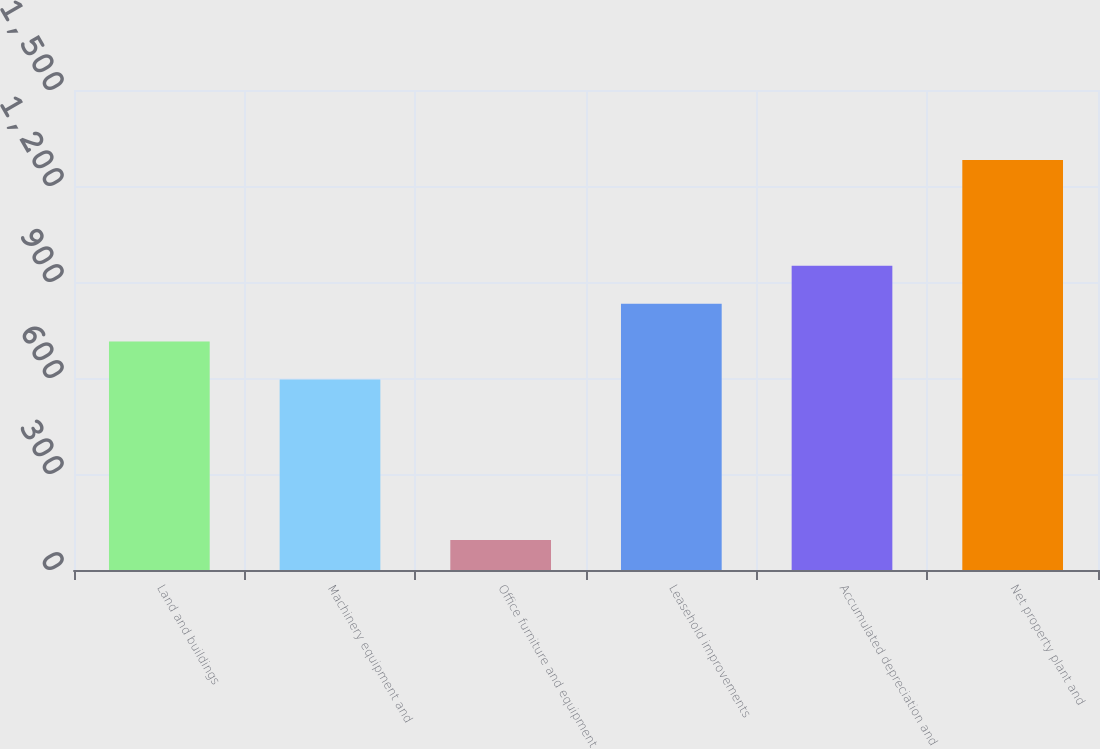<chart> <loc_0><loc_0><loc_500><loc_500><bar_chart><fcel>Land and buildings<fcel>Machinery equipment and<fcel>Office furniture and equipment<fcel>Leasehold improvements<fcel>Accumulated depreciation and<fcel>Net property plant and<nl><fcel>713.7<fcel>595<fcel>94<fcel>832.4<fcel>951.1<fcel>1281<nl></chart> 